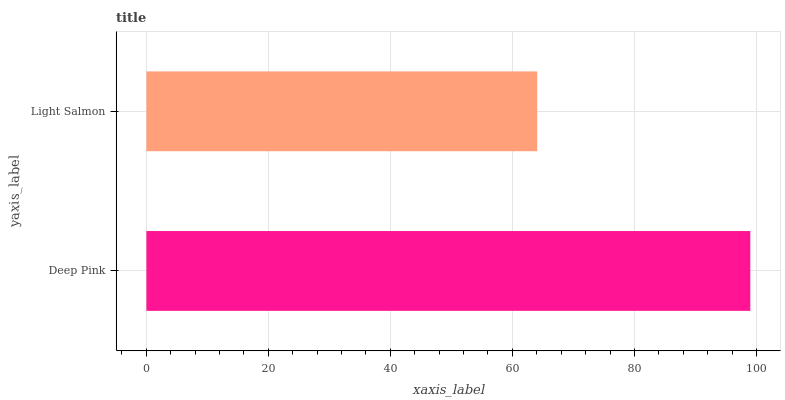Is Light Salmon the minimum?
Answer yes or no. Yes. Is Deep Pink the maximum?
Answer yes or no. Yes. Is Light Salmon the maximum?
Answer yes or no. No. Is Deep Pink greater than Light Salmon?
Answer yes or no. Yes. Is Light Salmon less than Deep Pink?
Answer yes or no. Yes. Is Light Salmon greater than Deep Pink?
Answer yes or no. No. Is Deep Pink less than Light Salmon?
Answer yes or no. No. Is Deep Pink the high median?
Answer yes or no. Yes. Is Light Salmon the low median?
Answer yes or no. Yes. Is Light Salmon the high median?
Answer yes or no. No. Is Deep Pink the low median?
Answer yes or no. No. 